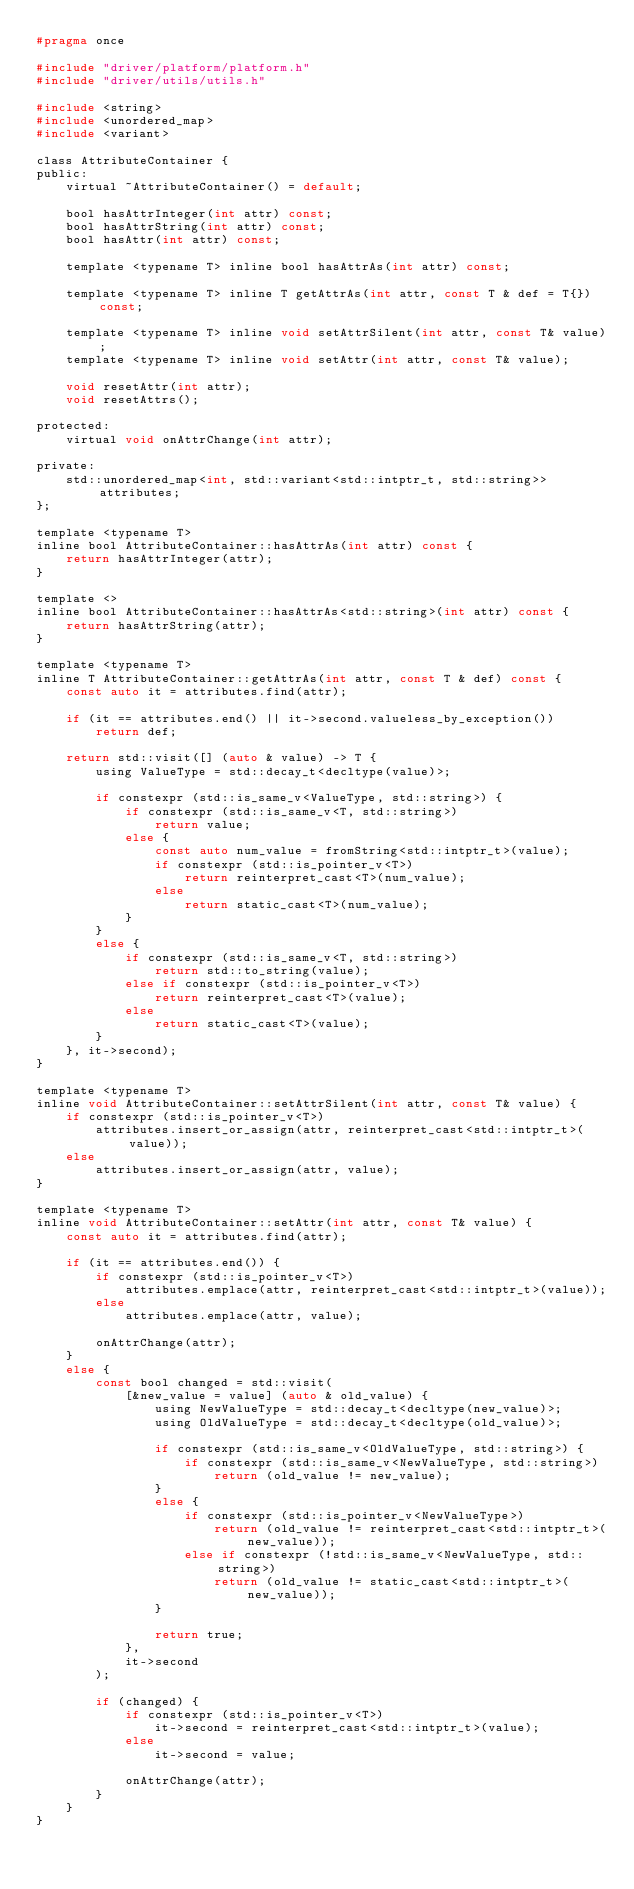Convert code to text. <code><loc_0><loc_0><loc_500><loc_500><_C_>#pragma once

#include "driver/platform/platform.h"
#include "driver/utils/utils.h"

#include <string>
#include <unordered_map>
#include <variant>

class AttributeContainer {
public:
    virtual ~AttributeContainer() = default;

    bool hasAttrInteger(int attr) const;
    bool hasAttrString(int attr) const;
    bool hasAttr(int attr) const;

    template <typename T> inline bool hasAttrAs(int attr) const;

    template <typename T> inline T getAttrAs(int attr, const T & def = T{}) const;

    template <typename T> inline void setAttrSilent(int attr, const T& value);
    template <typename T> inline void setAttr(int attr, const T& value);

    void resetAttr(int attr);
    void resetAttrs();

protected:
    virtual void onAttrChange(int attr);

private:
    std::unordered_map<int, std::variant<std::intptr_t, std::string>> attributes;
};

template <typename T>
inline bool AttributeContainer::hasAttrAs(int attr) const {
    return hasAttrInteger(attr);
}

template <>
inline bool AttributeContainer::hasAttrAs<std::string>(int attr) const {
    return hasAttrString(attr);
}

template <typename T>
inline T AttributeContainer::getAttrAs(int attr, const T & def) const {
    const auto it = attributes.find(attr);

    if (it == attributes.end() || it->second.valueless_by_exception())
        return def;

    return std::visit([] (auto & value) -> T {
        using ValueType = std::decay_t<decltype(value)>;

        if constexpr (std::is_same_v<ValueType, std::string>) {
            if constexpr (std::is_same_v<T, std::string>)
                return value;
            else {
                const auto num_value = fromString<std::intptr_t>(value);
                if constexpr (std::is_pointer_v<T>)
                    return reinterpret_cast<T>(num_value);
                else
                    return static_cast<T>(num_value);
            }
        }
        else {
            if constexpr (std::is_same_v<T, std::string>)
                return std::to_string(value);
            else if constexpr (std::is_pointer_v<T>)
                return reinterpret_cast<T>(value);
            else
                return static_cast<T>(value);
        }
    }, it->second);
}

template <typename T>
inline void AttributeContainer::setAttrSilent(int attr, const T& value) {
    if constexpr (std::is_pointer_v<T>)
        attributes.insert_or_assign(attr, reinterpret_cast<std::intptr_t>(value));
    else
        attributes.insert_or_assign(attr, value);
}

template <typename T>
inline void AttributeContainer::setAttr(int attr, const T& value) {
    const auto it = attributes.find(attr);

    if (it == attributes.end()) {
        if constexpr (std::is_pointer_v<T>)
            attributes.emplace(attr, reinterpret_cast<std::intptr_t>(value));
        else
            attributes.emplace(attr, value);

        onAttrChange(attr);
    }
    else {
        const bool changed = std::visit(
            [&new_value = value] (auto & old_value) {
                using NewValueType = std::decay_t<decltype(new_value)>;
                using OldValueType = std::decay_t<decltype(old_value)>;

                if constexpr (std::is_same_v<OldValueType, std::string>) {
                    if constexpr (std::is_same_v<NewValueType, std::string>)
                        return (old_value != new_value);
                }
                else {
                    if constexpr (std::is_pointer_v<NewValueType>)
                        return (old_value != reinterpret_cast<std::intptr_t>(new_value));
                    else if constexpr (!std::is_same_v<NewValueType, std::string>)
                        return (old_value != static_cast<std::intptr_t>(new_value));
                }

                return true;
            },
            it->second
        );

        if (changed) {
            if constexpr (std::is_pointer_v<T>)
                it->second = reinterpret_cast<std::intptr_t>(value);
            else
                it->second = value;

            onAttrChange(attr);
        }
    }
}
</code> 